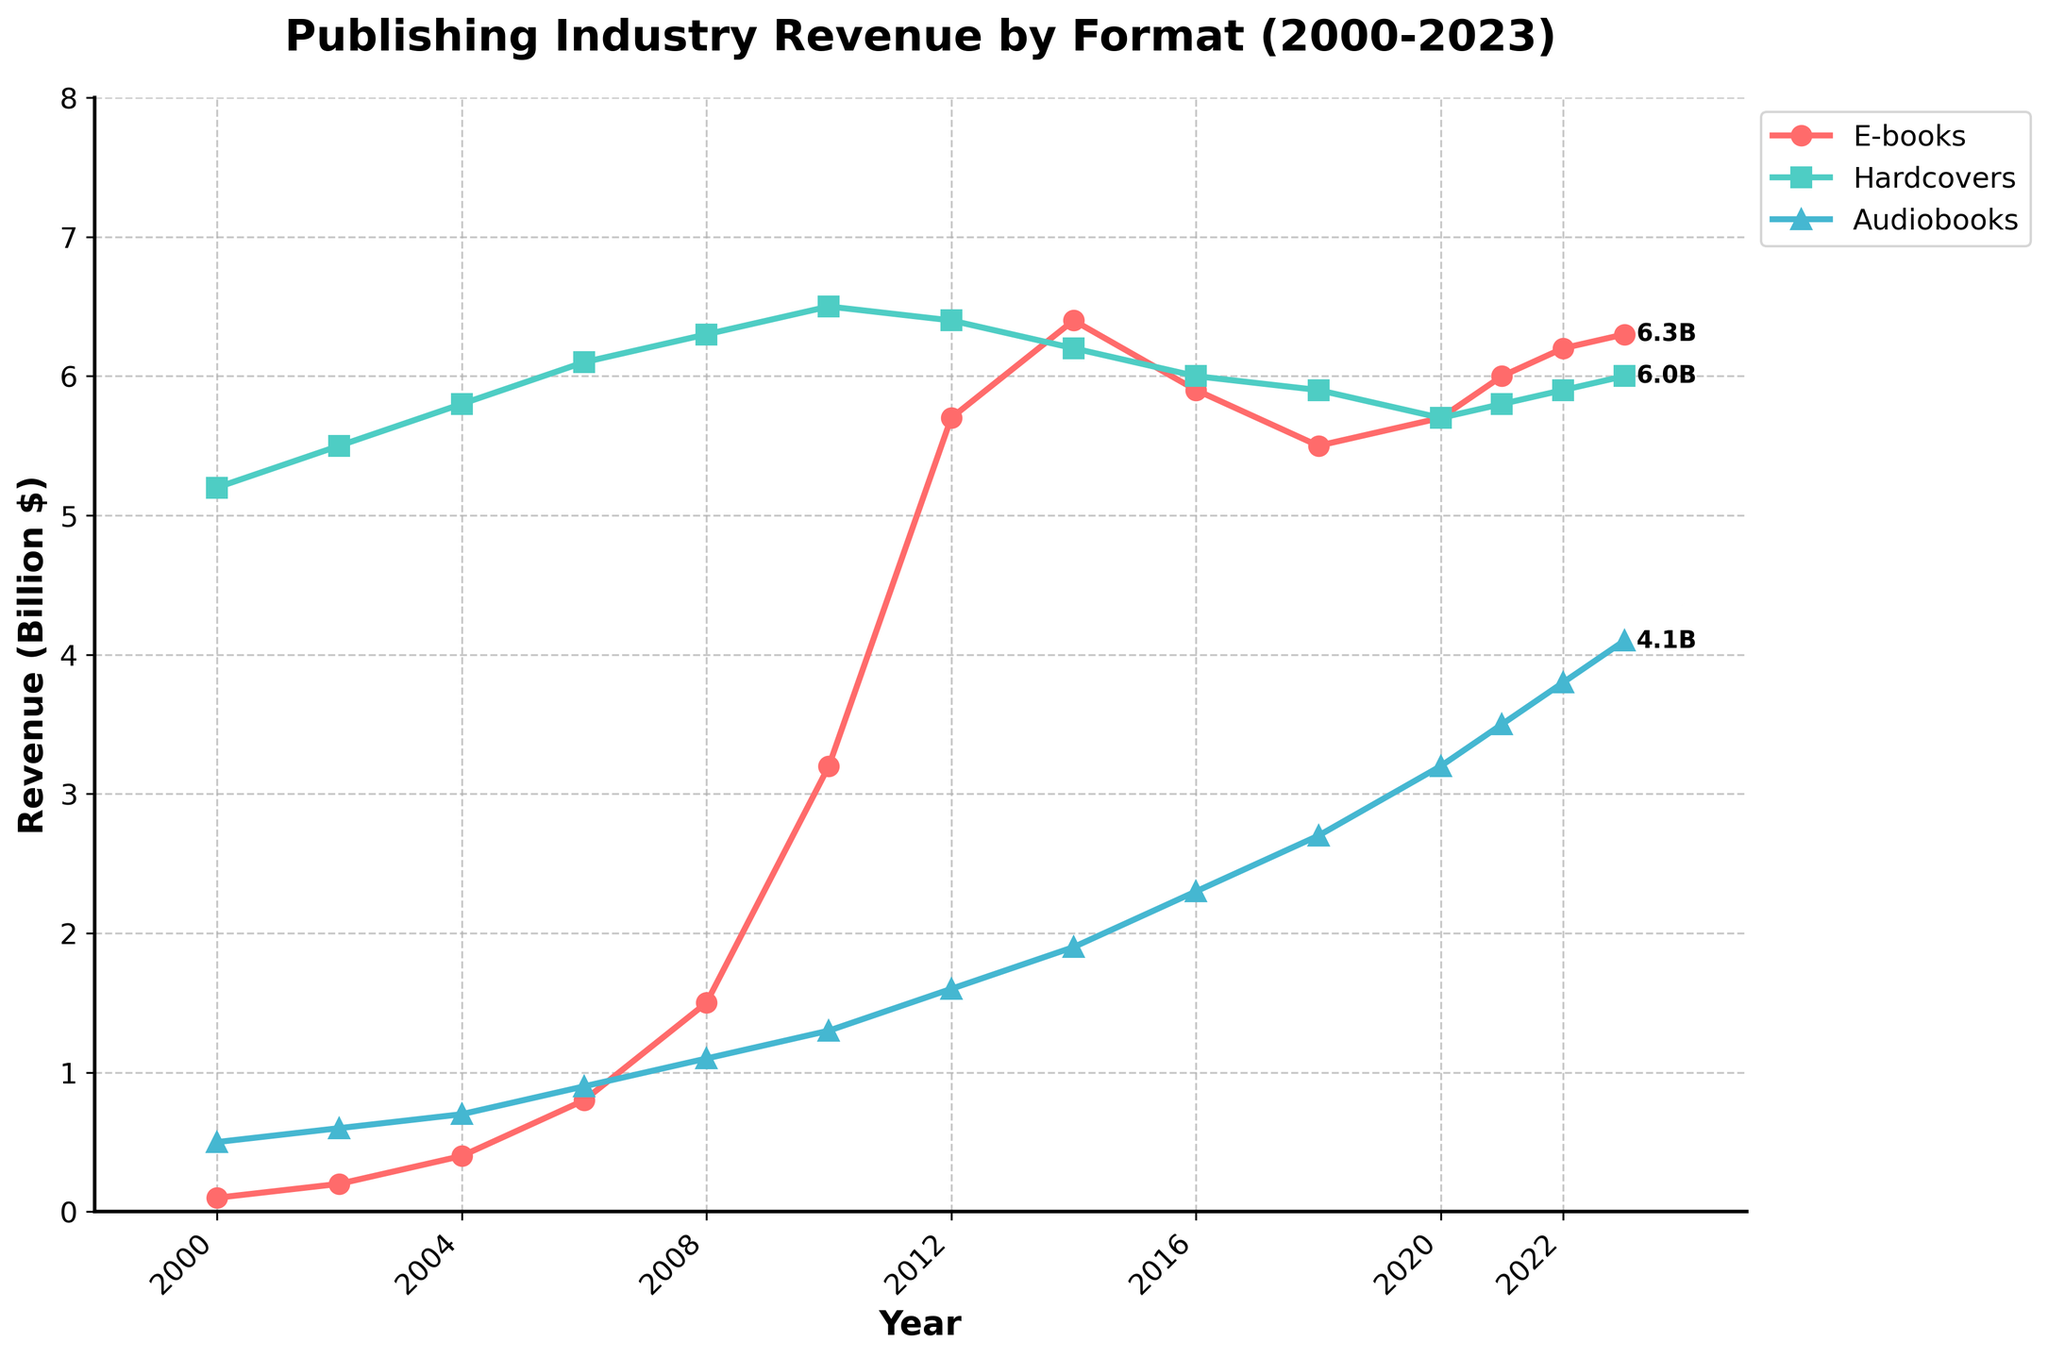What is the revenue of e-books in 2023? To determine the revenue of e-books in 2023, refer to the point on the e-books line at the year 2023. The value at this point is 6.3 billion dollars
Answer: 6.3 billion dollars Between which years did hardcovers revenue peak? Observe the hardcovers line to identify the highest value, which is around 6.5 billion dollars in the year 2010.
Answer: 2010 How did the revenue of audiobooks change from 2000 to 2023? Look at the starting point of the audiobooks line in 2000 (0.5 billion dollars) and the endpoint in 2023 (4.1 billion dollars). The revenue increased over this period.
Answer: Increased from 0.5 to 4.1 billion dollars What were the revenues of all three formats in 2006? Read the values from the lines at the year 2006. E-books: 0.8 billion, Hardcovers: 6.1 billion, Audiobooks: 0.9 billion.
Answer: E-books: 0.8 B, Hardcovers: 6.1 B, Audiobooks: 0.9 B How does the growth rate of e-books between 2000 and 2023 compare to that of audiobooks? Calculate the differences for both formats from 2000 to 2023. E-books increased from 0.1 to 6.3 (6.2 billion increase), audiobooks from 0.5 to 4.1 (3.6 billion increase). E-books grew faster.
Answer: E-books grew faster What is the difference in revenue between hardcovers and audiobooks in 2023? Find the values for both formats in 2023. Hardcovers: 6.0 billion, Audiobooks: 4.1 billion. Subtract the lower from the higher: 6.0 - 4.1 = 1.9 billion dollars.
Answer: 1.9 billion dollars Did hardcovers' revenue ever decrease over this period? Analyze the trend of the hardcovers line. It peaks at 6.5 billion in 2010 and then displays a slight downward trend to around 5.9 billion in 2023, indicating a decrease post-2010.
Answer: Yes Which format shows the highest increase in revenue from 2000 to 2023? Compare the differences: E-books increased from 0.1 to 6.3 (6.2 billion increase), Hardcovers: 5.2 to 6.0 (0.8 billion increase), Audiobooks: 0.5 to 4.1 (3.6 billion increase). E-books show the highest increase.
Answer: E-books At what year did e-books surpass 5 billion in revenue for the first time? Identify the point where the e-books line crosses the 5 billion mark. This occurs between 2010 and 2012. In 2012, the e-books revenue is 5.7 billion.
Answer: 2012 Which format has the most consistent revenue over the years? The hardcovers line is relatively flat compared to the rising trends of e-books and audiobooks, indicating the most consistency.
Answer: Hardcovers 